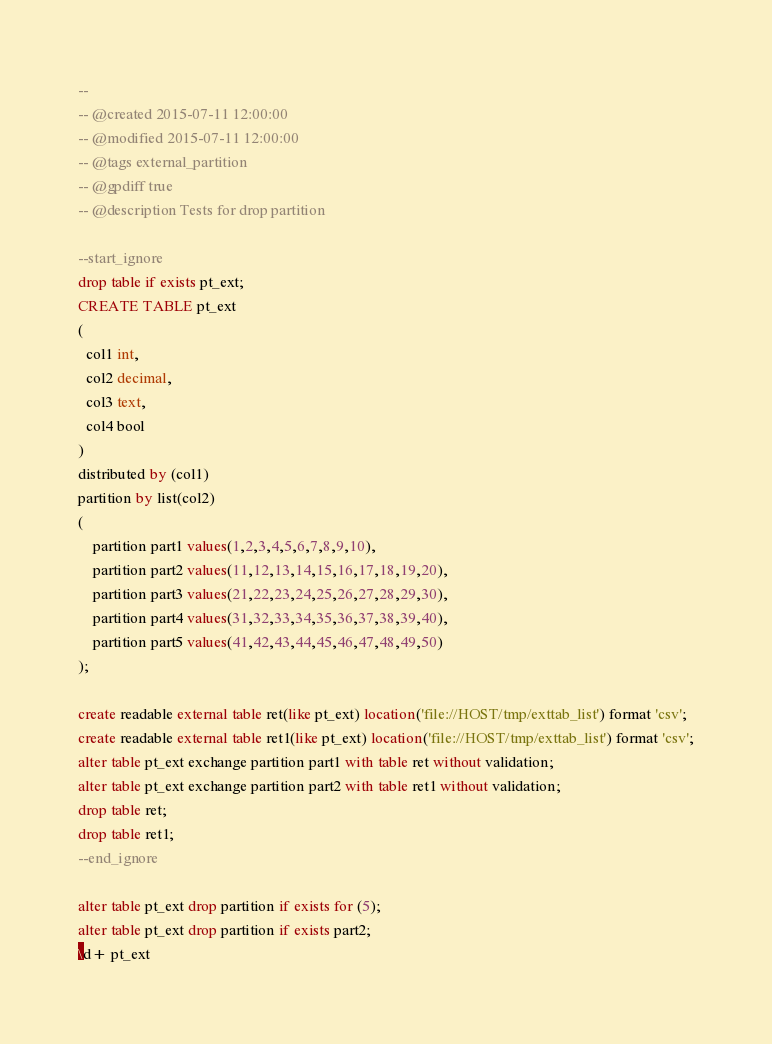Convert code to text. <code><loc_0><loc_0><loc_500><loc_500><_SQL_>-- 
-- @created 2015-07-11 12:00:00
-- @modified 2015-07-11 12:00:00
-- @tags external_partition 
-- @gpdiff true 
-- @description Tests for drop partition 

--start_ignore
drop table if exists pt_ext;
CREATE TABLE pt_ext
(
  col1 int,
  col2 decimal,
  col3 text,
  col4 bool
)
distributed by (col1)
partition by list(col2)
(
	partition part1 values(1,2,3,4,5,6,7,8,9,10),
	partition part2 values(11,12,13,14,15,16,17,18,19,20),
	partition part3 values(21,22,23,24,25,26,27,28,29,30),
	partition part4 values(31,32,33,34,35,36,37,38,39,40),
	partition part5 values(41,42,43,44,45,46,47,48,49,50)
);

create readable external table ret(like pt_ext) location('file://HOST/tmp/exttab_list') format 'csv';
create readable external table ret1(like pt_ext) location('file://HOST/tmp/exttab_list') format 'csv';
alter table pt_ext exchange partition part1 with table ret without validation;
alter table pt_ext exchange partition part2 with table ret1 without validation;
drop table ret;
drop table ret1;
--end_ignore

alter table pt_ext drop partition if exists for (5); 
alter table pt_ext drop partition if exists part2;
\d+ pt_ext
</code> 